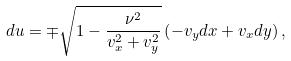<formula> <loc_0><loc_0><loc_500><loc_500>d u = \mp \sqrt { 1 - \frac { \nu ^ { 2 } } { v _ { x } ^ { 2 } + v _ { y } ^ { 2 } } } \left ( - v _ { y } d x + v _ { x } d y \right ) ,</formula> 